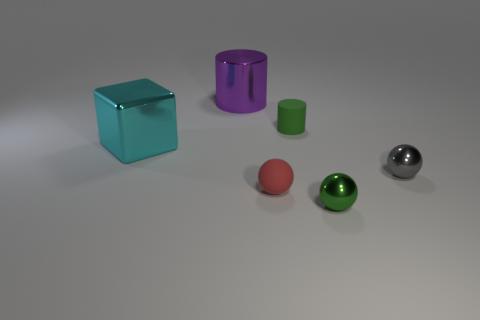Is the number of green things to the right of the green rubber object the same as the number of cyan blocks?
Ensure brevity in your answer.  Yes. Is there a cylinder that has the same material as the red thing?
Give a very brief answer. Yes. Do the big thing to the right of the metal cube and the green object left of the green metal sphere have the same shape?
Provide a succinct answer. Yes. Are any tiny cyan shiny spheres visible?
Your response must be concise. No. There is a shiny cube that is the same size as the purple shiny cylinder; what is its color?
Your answer should be very brief. Cyan. What number of metal things have the same shape as the red matte thing?
Your answer should be very brief. 2. Does the large thing to the left of the large purple metal cylinder have the same material as the purple object?
Your response must be concise. Yes. How many cylinders are either large purple metal objects or small gray shiny objects?
Ensure brevity in your answer.  1. There is a small rubber object that is in front of the big metal object that is in front of the big purple shiny cylinder that is behind the tiny red ball; what shape is it?
Ensure brevity in your answer.  Sphere. There is a metal object that is the same color as the tiny matte cylinder; what is its shape?
Offer a very short reply. Sphere. 